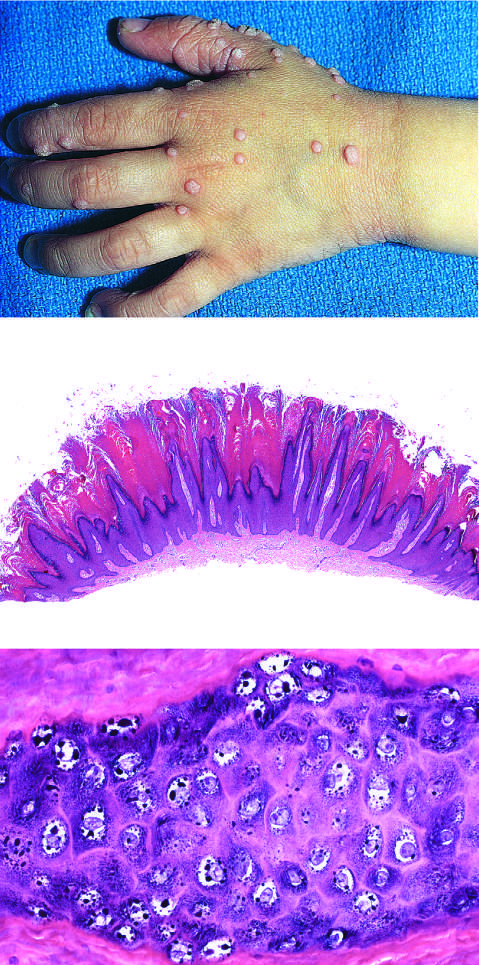what are seen at higher magnification (bottom)?
Answer the question using a single word or phrase. Cytopathic changes 